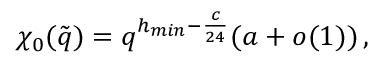Convert formula to latex. <formula><loc_0><loc_0><loc_500><loc_500>\chi _ { 0 } ( \tilde { q } ) = q ^ { h _ { \min } - \frac { c } { 2 4 } } ( a + o ( 1 ) ) \, ,</formula> 